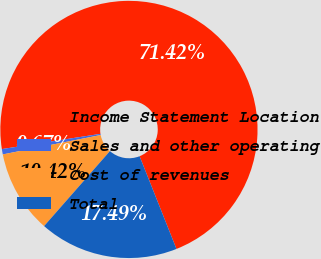Convert chart to OTSL. <chart><loc_0><loc_0><loc_500><loc_500><pie_chart><fcel>Income Statement Location<fcel>Sales and other operating<fcel>Cost of revenues<fcel>Total<nl><fcel>71.41%<fcel>0.67%<fcel>10.42%<fcel>17.49%<nl></chart> 